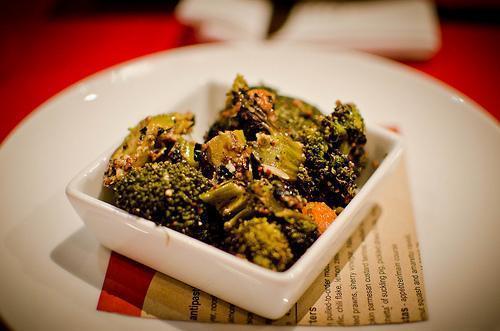How many dishes?
Give a very brief answer. 1. 